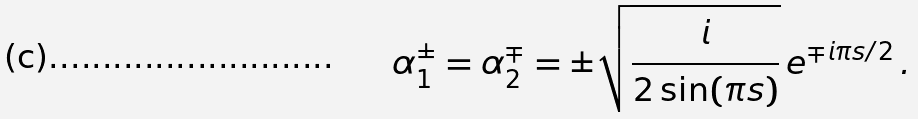Convert formula to latex. <formula><loc_0><loc_0><loc_500><loc_500>\alpha _ { 1 } ^ { \pm } = \alpha _ { 2 } ^ { \mp } = \pm \sqrt { \frac { i } { 2 \sin ( \pi s ) } } \, e ^ { \mp i \pi s / 2 } \, .</formula> 